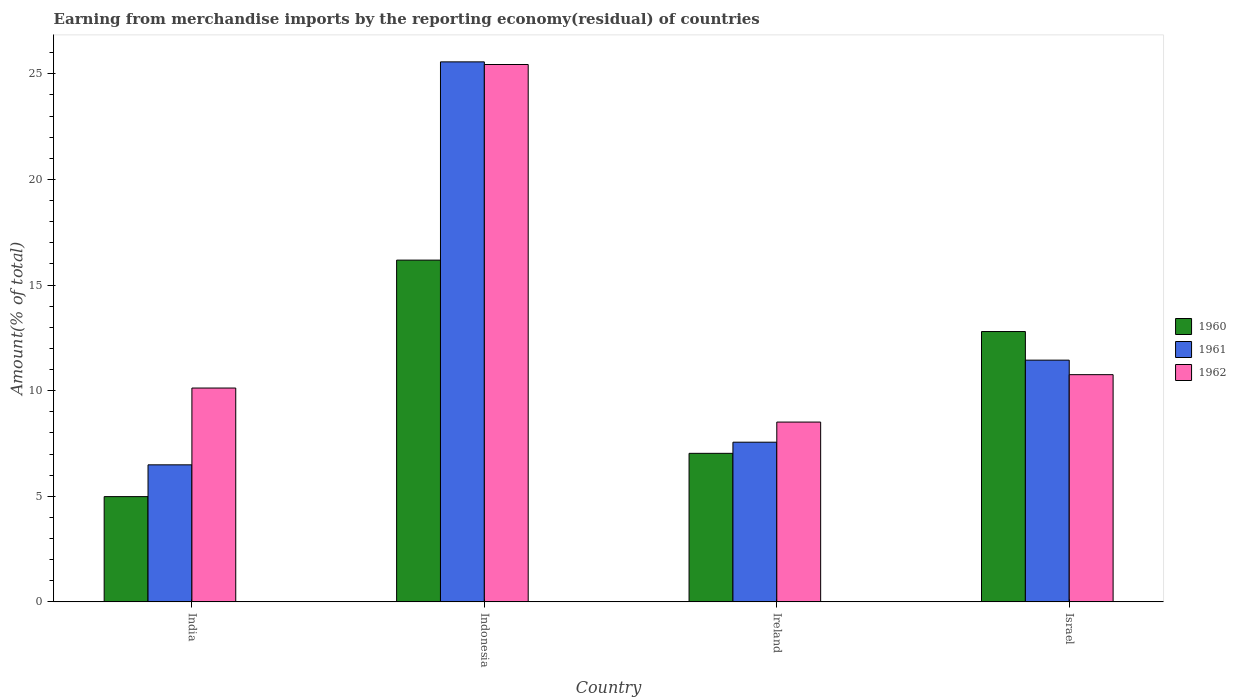Are the number of bars per tick equal to the number of legend labels?
Your answer should be very brief. Yes. What is the label of the 1st group of bars from the left?
Your answer should be very brief. India. What is the percentage of amount earned from merchandise imports in 1962 in India?
Offer a very short reply. 10.12. Across all countries, what is the maximum percentage of amount earned from merchandise imports in 1962?
Your answer should be very brief. 25.44. Across all countries, what is the minimum percentage of amount earned from merchandise imports in 1961?
Provide a succinct answer. 6.49. In which country was the percentage of amount earned from merchandise imports in 1962 maximum?
Provide a succinct answer. Indonesia. In which country was the percentage of amount earned from merchandise imports in 1962 minimum?
Your answer should be very brief. Ireland. What is the total percentage of amount earned from merchandise imports in 1962 in the graph?
Your answer should be compact. 54.84. What is the difference between the percentage of amount earned from merchandise imports in 1961 in Indonesia and that in Israel?
Offer a very short reply. 14.12. What is the difference between the percentage of amount earned from merchandise imports in 1960 in Israel and the percentage of amount earned from merchandise imports in 1961 in Indonesia?
Offer a very short reply. -12.77. What is the average percentage of amount earned from merchandise imports in 1961 per country?
Keep it short and to the point. 12.77. What is the difference between the percentage of amount earned from merchandise imports of/in 1961 and percentage of amount earned from merchandise imports of/in 1960 in Israel?
Provide a succinct answer. -1.35. What is the ratio of the percentage of amount earned from merchandise imports in 1962 in India to that in Indonesia?
Your answer should be compact. 0.4. Is the percentage of amount earned from merchandise imports in 1961 in India less than that in Israel?
Provide a short and direct response. Yes. Is the difference between the percentage of amount earned from merchandise imports in 1961 in Indonesia and Israel greater than the difference between the percentage of amount earned from merchandise imports in 1960 in Indonesia and Israel?
Make the answer very short. Yes. What is the difference between the highest and the second highest percentage of amount earned from merchandise imports in 1960?
Give a very brief answer. 3.38. What is the difference between the highest and the lowest percentage of amount earned from merchandise imports in 1961?
Your answer should be very brief. 19.08. In how many countries, is the percentage of amount earned from merchandise imports in 1960 greater than the average percentage of amount earned from merchandise imports in 1960 taken over all countries?
Keep it short and to the point. 2. Is the sum of the percentage of amount earned from merchandise imports in 1962 in India and Israel greater than the maximum percentage of amount earned from merchandise imports in 1960 across all countries?
Provide a short and direct response. Yes. What does the 1st bar from the left in Israel represents?
Your answer should be very brief. 1960. Is it the case that in every country, the sum of the percentage of amount earned from merchandise imports in 1960 and percentage of amount earned from merchandise imports in 1962 is greater than the percentage of amount earned from merchandise imports in 1961?
Your answer should be very brief. Yes. Are all the bars in the graph horizontal?
Offer a very short reply. No. Are the values on the major ticks of Y-axis written in scientific E-notation?
Offer a terse response. No. Does the graph contain any zero values?
Give a very brief answer. No. Does the graph contain grids?
Make the answer very short. No. How many legend labels are there?
Provide a short and direct response. 3. What is the title of the graph?
Give a very brief answer. Earning from merchandise imports by the reporting economy(residual) of countries. Does "1964" appear as one of the legend labels in the graph?
Your response must be concise. No. What is the label or title of the Y-axis?
Keep it short and to the point. Amount(% of total). What is the Amount(% of total) in 1960 in India?
Your answer should be very brief. 4.98. What is the Amount(% of total) of 1961 in India?
Your answer should be compact. 6.49. What is the Amount(% of total) in 1962 in India?
Make the answer very short. 10.12. What is the Amount(% of total) of 1960 in Indonesia?
Offer a very short reply. 16.18. What is the Amount(% of total) of 1961 in Indonesia?
Offer a very short reply. 25.57. What is the Amount(% of total) in 1962 in Indonesia?
Your answer should be compact. 25.44. What is the Amount(% of total) of 1960 in Ireland?
Your answer should be very brief. 7.03. What is the Amount(% of total) in 1961 in Ireland?
Provide a short and direct response. 7.56. What is the Amount(% of total) in 1962 in Ireland?
Offer a terse response. 8.51. What is the Amount(% of total) in 1960 in Israel?
Provide a succinct answer. 12.8. What is the Amount(% of total) in 1961 in Israel?
Provide a succinct answer. 11.45. What is the Amount(% of total) in 1962 in Israel?
Provide a succinct answer. 10.76. Across all countries, what is the maximum Amount(% of total) of 1960?
Your answer should be compact. 16.18. Across all countries, what is the maximum Amount(% of total) of 1961?
Make the answer very short. 25.57. Across all countries, what is the maximum Amount(% of total) of 1962?
Make the answer very short. 25.44. Across all countries, what is the minimum Amount(% of total) of 1960?
Your response must be concise. 4.98. Across all countries, what is the minimum Amount(% of total) of 1961?
Offer a terse response. 6.49. Across all countries, what is the minimum Amount(% of total) in 1962?
Your answer should be very brief. 8.51. What is the total Amount(% of total) of 1960 in the graph?
Give a very brief answer. 41. What is the total Amount(% of total) in 1961 in the graph?
Offer a terse response. 51.06. What is the total Amount(% of total) of 1962 in the graph?
Your answer should be compact. 54.84. What is the difference between the Amount(% of total) of 1960 in India and that in Indonesia?
Offer a very short reply. -11.2. What is the difference between the Amount(% of total) in 1961 in India and that in Indonesia?
Provide a succinct answer. -19.08. What is the difference between the Amount(% of total) of 1962 in India and that in Indonesia?
Offer a terse response. -15.32. What is the difference between the Amount(% of total) of 1960 in India and that in Ireland?
Provide a short and direct response. -2.05. What is the difference between the Amount(% of total) in 1961 in India and that in Ireland?
Make the answer very short. -1.07. What is the difference between the Amount(% of total) of 1962 in India and that in Ireland?
Give a very brief answer. 1.61. What is the difference between the Amount(% of total) of 1960 in India and that in Israel?
Your response must be concise. -7.82. What is the difference between the Amount(% of total) in 1961 in India and that in Israel?
Your answer should be very brief. -4.96. What is the difference between the Amount(% of total) of 1962 in India and that in Israel?
Provide a succinct answer. -0.63. What is the difference between the Amount(% of total) of 1960 in Indonesia and that in Ireland?
Ensure brevity in your answer.  9.15. What is the difference between the Amount(% of total) of 1961 in Indonesia and that in Ireland?
Provide a succinct answer. 18.01. What is the difference between the Amount(% of total) of 1962 in Indonesia and that in Ireland?
Ensure brevity in your answer.  16.93. What is the difference between the Amount(% of total) of 1960 in Indonesia and that in Israel?
Provide a succinct answer. 3.38. What is the difference between the Amount(% of total) of 1961 in Indonesia and that in Israel?
Ensure brevity in your answer.  14.12. What is the difference between the Amount(% of total) of 1962 in Indonesia and that in Israel?
Your answer should be compact. 14.69. What is the difference between the Amount(% of total) of 1960 in Ireland and that in Israel?
Keep it short and to the point. -5.77. What is the difference between the Amount(% of total) in 1961 in Ireland and that in Israel?
Your answer should be compact. -3.88. What is the difference between the Amount(% of total) of 1962 in Ireland and that in Israel?
Your answer should be compact. -2.24. What is the difference between the Amount(% of total) of 1960 in India and the Amount(% of total) of 1961 in Indonesia?
Your answer should be very brief. -20.58. What is the difference between the Amount(% of total) of 1960 in India and the Amount(% of total) of 1962 in Indonesia?
Give a very brief answer. -20.46. What is the difference between the Amount(% of total) in 1961 in India and the Amount(% of total) in 1962 in Indonesia?
Provide a short and direct response. -18.95. What is the difference between the Amount(% of total) of 1960 in India and the Amount(% of total) of 1961 in Ireland?
Provide a short and direct response. -2.58. What is the difference between the Amount(% of total) of 1960 in India and the Amount(% of total) of 1962 in Ireland?
Your answer should be compact. -3.53. What is the difference between the Amount(% of total) of 1961 in India and the Amount(% of total) of 1962 in Ireland?
Provide a short and direct response. -2.03. What is the difference between the Amount(% of total) of 1960 in India and the Amount(% of total) of 1961 in Israel?
Your answer should be very brief. -6.46. What is the difference between the Amount(% of total) in 1960 in India and the Amount(% of total) in 1962 in Israel?
Keep it short and to the point. -5.77. What is the difference between the Amount(% of total) in 1961 in India and the Amount(% of total) in 1962 in Israel?
Offer a very short reply. -4.27. What is the difference between the Amount(% of total) of 1960 in Indonesia and the Amount(% of total) of 1961 in Ireland?
Make the answer very short. 8.62. What is the difference between the Amount(% of total) in 1960 in Indonesia and the Amount(% of total) in 1962 in Ireland?
Provide a succinct answer. 7.67. What is the difference between the Amount(% of total) of 1961 in Indonesia and the Amount(% of total) of 1962 in Ireland?
Provide a short and direct response. 17.05. What is the difference between the Amount(% of total) in 1960 in Indonesia and the Amount(% of total) in 1961 in Israel?
Make the answer very short. 4.74. What is the difference between the Amount(% of total) in 1960 in Indonesia and the Amount(% of total) in 1962 in Israel?
Keep it short and to the point. 5.42. What is the difference between the Amount(% of total) in 1961 in Indonesia and the Amount(% of total) in 1962 in Israel?
Keep it short and to the point. 14.81. What is the difference between the Amount(% of total) of 1960 in Ireland and the Amount(% of total) of 1961 in Israel?
Your answer should be compact. -4.41. What is the difference between the Amount(% of total) of 1960 in Ireland and the Amount(% of total) of 1962 in Israel?
Offer a very short reply. -3.72. What is the difference between the Amount(% of total) in 1961 in Ireland and the Amount(% of total) in 1962 in Israel?
Your answer should be very brief. -3.2. What is the average Amount(% of total) of 1960 per country?
Provide a short and direct response. 10.25. What is the average Amount(% of total) of 1961 per country?
Provide a succinct answer. 12.77. What is the average Amount(% of total) of 1962 per country?
Your answer should be very brief. 13.71. What is the difference between the Amount(% of total) of 1960 and Amount(% of total) of 1961 in India?
Offer a very short reply. -1.5. What is the difference between the Amount(% of total) in 1960 and Amount(% of total) in 1962 in India?
Offer a terse response. -5.14. What is the difference between the Amount(% of total) of 1961 and Amount(% of total) of 1962 in India?
Give a very brief answer. -3.64. What is the difference between the Amount(% of total) in 1960 and Amount(% of total) in 1961 in Indonesia?
Keep it short and to the point. -9.39. What is the difference between the Amount(% of total) of 1960 and Amount(% of total) of 1962 in Indonesia?
Your response must be concise. -9.26. What is the difference between the Amount(% of total) of 1961 and Amount(% of total) of 1962 in Indonesia?
Offer a terse response. 0.12. What is the difference between the Amount(% of total) in 1960 and Amount(% of total) in 1961 in Ireland?
Ensure brevity in your answer.  -0.53. What is the difference between the Amount(% of total) in 1960 and Amount(% of total) in 1962 in Ireland?
Your answer should be compact. -1.48. What is the difference between the Amount(% of total) in 1961 and Amount(% of total) in 1962 in Ireland?
Give a very brief answer. -0.95. What is the difference between the Amount(% of total) in 1960 and Amount(% of total) in 1961 in Israel?
Your response must be concise. 1.35. What is the difference between the Amount(% of total) of 1960 and Amount(% of total) of 1962 in Israel?
Ensure brevity in your answer.  2.04. What is the difference between the Amount(% of total) in 1961 and Amount(% of total) in 1962 in Israel?
Ensure brevity in your answer.  0.69. What is the ratio of the Amount(% of total) in 1960 in India to that in Indonesia?
Your answer should be compact. 0.31. What is the ratio of the Amount(% of total) in 1961 in India to that in Indonesia?
Your answer should be compact. 0.25. What is the ratio of the Amount(% of total) of 1962 in India to that in Indonesia?
Offer a very short reply. 0.4. What is the ratio of the Amount(% of total) in 1960 in India to that in Ireland?
Give a very brief answer. 0.71. What is the ratio of the Amount(% of total) in 1961 in India to that in Ireland?
Offer a terse response. 0.86. What is the ratio of the Amount(% of total) in 1962 in India to that in Ireland?
Offer a terse response. 1.19. What is the ratio of the Amount(% of total) in 1960 in India to that in Israel?
Your answer should be compact. 0.39. What is the ratio of the Amount(% of total) of 1961 in India to that in Israel?
Give a very brief answer. 0.57. What is the ratio of the Amount(% of total) in 1962 in India to that in Israel?
Your response must be concise. 0.94. What is the ratio of the Amount(% of total) in 1960 in Indonesia to that in Ireland?
Your response must be concise. 2.3. What is the ratio of the Amount(% of total) of 1961 in Indonesia to that in Ireland?
Provide a short and direct response. 3.38. What is the ratio of the Amount(% of total) of 1962 in Indonesia to that in Ireland?
Offer a terse response. 2.99. What is the ratio of the Amount(% of total) in 1960 in Indonesia to that in Israel?
Offer a terse response. 1.26. What is the ratio of the Amount(% of total) in 1961 in Indonesia to that in Israel?
Ensure brevity in your answer.  2.23. What is the ratio of the Amount(% of total) in 1962 in Indonesia to that in Israel?
Give a very brief answer. 2.37. What is the ratio of the Amount(% of total) in 1960 in Ireland to that in Israel?
Ensure brevity in your answer.  0.55. What is the ratio of the Amount(% of total) of 1961 in Ireland to that in Israel?
Make the answer very short. 0.66. What is the ratio of the Amount(% of total) in 1962 in Ireland to that in Israel?
Ensure brevity in your answer.  0.79. What is the difference between the highest and the second highest Amount(% of total) of 1960?
Your response must be concise. 3.38. What is the difference between the highest and the second highest Amount(% of total) of 1961?
Give a very brief answer. 14.12. What is the difference between the highest and the second highest Amount(% of total) in 1962?
Your answer should be very brief. 14.69. What is the difference between the highest and the lowest Amount(% of total) of 1960?
Your answer should be compact. 11.2. What is the difference between the highest and the lowest Amount(% of total) in 1961?
Your answer should be compact. 19.08. What is the difference between the highest and the lowest Amount(% of total) in 1962?
Offer a terse response. 16.93. 